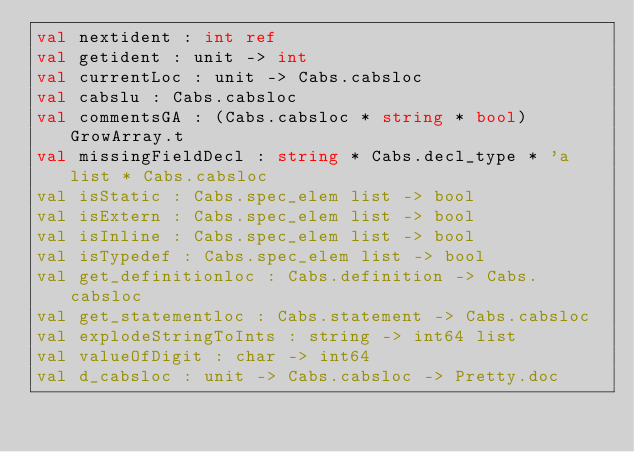Convert code to text. <code><loc_0><loc_0><loc_500><loc_500><_OCaml_>val nextident : int ref
val getident : unit -> int
val currentLoc : unit -> Cabs.cabsloc
val cabslu : Cabs.cabsloc
val commentsGA : (Cabs.cabsloc * string * bool) GrowArray.t
val missingFieldDecl : string * Cabs.decl_type * 'a list * Cabs.cabsloc
val isStatic : Cabs.spec_elem list -> bool
val isExtern : Cabs.spec_elem list -> bool
val isInline : Cabs.spec_elem list -> bool
val isTypedef : Cabs.spec_elem list -> bool
val get_definitionloc : Cabs.definition -> Cabs.cabsloc
val get_statementloc : Cabs.statement -> Cabs.cabsloc
val explodeStringToInts : string -> int64 list
val valueOfDigit : char -> int64
val d_cabsloc : unit -> Cabs.cabsloc -> Pretty.doc
</code> 